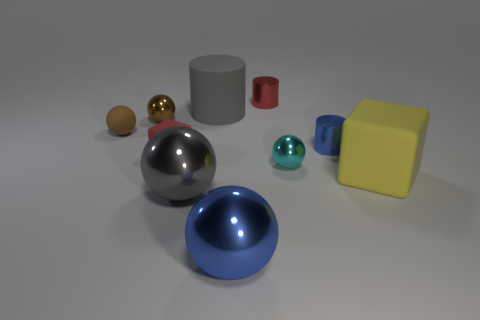Does the red cylinder have the same size as the yellow block?
Offer a very short reply. No. What is the shape of the yellow thing that is made of the same material as the big cylinder?
Make the answer very short. Cube. How many other things are the same shape as the red metal thing?
Give a very brief answer. 2. There is a red thing that is to the left of the cylinder behind the big matte object that is behind the cyan metal object; what shape is it?
Keep it short and to the point. Cube. How many blocks are either small brown rubber things or yellow rubber things?
Keep it short and to the point. 1. There is a big gray thing that is on the left side of the matte cylinder; are there any large rubber objects in front of it?
Provide a short and direct response. No. Is there any other thing that is made of the same material as the tiny cyan thing?
Keep it short and to the point. Yes. Is the shape of the big gray rubber object the same as the big blue metallic object that is on the left side of the large yellow object?
Give a very brief answer. No. What number of other things are there of the same size as the red cylinder?
Provide a short and direct response. 5. What number of red things are small blocks or blocks?
Ensure brevity in your answer.  1. 